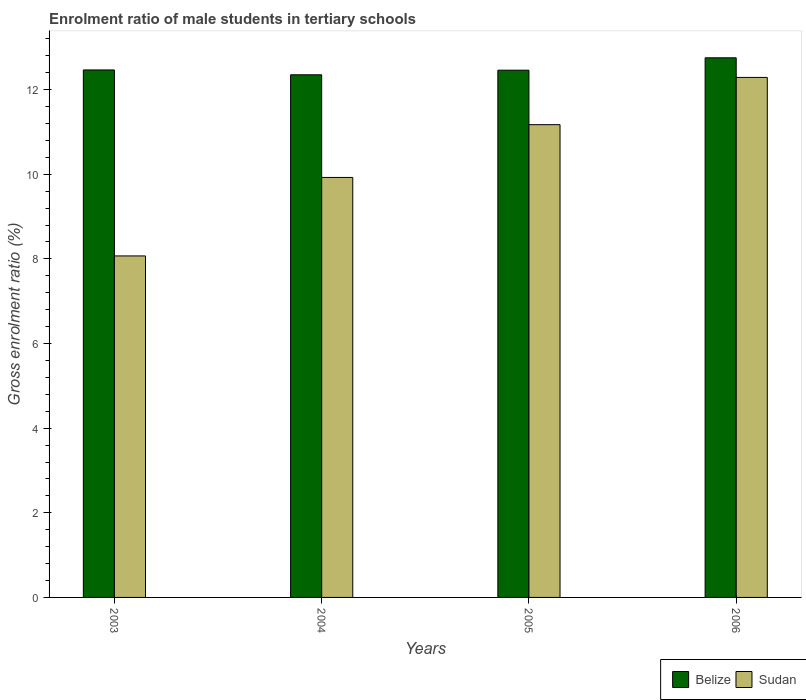How many different coloured bars are there?
Make the answer very short. 2. How many groups of bars are there?
Give a very brief answer. 4. Are the number of bars per tick equal to the number of legend labels?
Offer a very short reply. Yes. Are the number of bars on each tick of the X-axis equal?
Offer a terse response. Yes. How many bars are there on the 3rd tick from the left?
Your response must be concise. 2. What is the enrolment ratio of male students in tertiary schools in Sudan in 2004?
Your response must be concise. 9.92. Across all years, what is the maximum enrolment ratio of male students in tertiary schools in Sudan?
Provide a succinct answer. 12.29. Across all years, what is the minimum enrolment ratio of male students in tertiary schools in Sudan?
Your answer should be compact. 8.07. What is the total enrolment ratio of male students in tertiary schools in Sudan in the graph?
Offer a terse response. 41.45. What is the difference between the enrolment ratio of male students in tertiary schools in Belize in 2003 and that in 2005?
Your answer should be very brief. 0.01. What is the difference between the enrolment ratio of male students in tertiary schools in Sudan in 2003 and the enrolment ratio of male students in tertiary schools in Belize in 2004?
Offer a terse response. -4.28. What is the average enrolment ratio of male students in tertiary schools in Belize per year?
Offer a terse response. 12.51. In the year 2004, what is the difference between the enrolment ratio of male students in tertiary schools in Belize and enrolment ratio of male students in tertiary schools in Sudan?
Give a very brief answer. 2.43. What is the ratio of the enrolment ratio of male students in tertiary schools in Sudan in 2003 to that in 2004?
Keep it short and to the point. 0.81. Is the enrolment ratio of male students in tertiary schools in Sudan in 2003 less than that in 2005?
Provide a succinct answer. Yes. What is the difference between the highest and the second highest enrolment ratio of male students in tertiary schools in Sudan?
Your answer should be very brief. 1.12. What is the difference between the highest and the lowest enrolment ratio of male students in tertiary schools in Sudan?
Your response must be concise. 4.22. What does the 1st bar from the left in 2005 represents?
Provide a short and direct response. Belize. What does the 2nd bar from the right in 2005 represents?
Provide a short and direct response. Belize. How many bars are there?
Ensure brevity in your answer.  8. Are all the bars in the graph horizontal?
Provide a short and direct response. No. Does the graph contain any zero values?
Provide a short and direct response. No. How are the legend labels stacked?
Your answer should be compact. Horizontal. What is the title of the graph?
Give a very brief answer. Enrolment ratio of male students in tertiary schools. Does "Honduras" appear as one of the legend labels in the graph?
Your answer should be compact. No. What is the label or title of the Y-axis?
Your response must be concise. Gross enrolment ratio (%). What is the Gross enrolment ratio (%) of Belize in 2003?
Offer a terse response. 12.47. What is the Gross enrolment ratio (%) in Sudan in 2003?
Offer a terse response. 8.07. What is the Gross enrolment ratio (%) in Belize in 2004?
Your answer should be very brief. 12.35. What is the Gross enrolment ratio (%) of Sudan in 2004?
Your response must be concise. 9.92. What is the Gross enrolment ratio (%) in Belize in 2005?
Provide a succinct answer. 12.46. What is the Gross enrolment ratio (%) in Sudan in 2005?
Make the answer very short. 11.17. What is the Gross enrolment ratio (%) in Belize in 2006?
Make the answer very short. 12.75. What is the Gross enrolment ratio (%) of Sudan in 2006?
Your answer should be compact. 12.29. Across all years, what is the maximum Gross enrolment ratio (%) of Belize?
Keep it short and to the point. 12.75. Across all years, what is the maximum Gross enrolment ratio (%) of Sudan?
Your answer should be compact. 12.29. Across all years, what is the minimum Gross enrolment ratio (%) in Belize?
Your response must be concise. 12.35. Across all years, what is the minimum Gross enrolment ratio (%) in Sudan?
Provide a short and direct response. 8.07. What is the total Gross enrolment ratio (%) in Belize in the graph?
Offer a terse response. 50.03. What is the total Gross enrolment ratio (%) of Sudan in the graph?
Your answer should be very brief. 41.45. What is the difference between the Gross enrolment ratio (%) of Belize in 2003 and that in 2004?
Your response must be concise. 0.11. What is the difference between the Gross enrolment ratio (%) in Sudan in 2003 and that in 2004?
Your answer should be very brief. -1.85. What is the difference between the Gross enrolment ratio (%) in Belize in 2003 and that in 2005?
Your response must be concise. 0.01. What is the difference between the Gross enrolment ratio (%) of Sudan in 2003 and that in 2005?
Your answer should be very brief. -3.1. What is the difference between the Gross enrolment ratio (%) in Belize in 2003 and that in 2006?
Offer a very short reply. -0.29. What is the difference between the Gross enrolment ratio (%) of Sudan in 2003 and that in 2006?
Your response must be concise. -4.22. What is the difference between the Gross enrolment ratio (%) in Belize in 2004 and that in 2005?
Your answer should be compact. -0.11. What is the difference between the Gross enrolment ratio (%) of Sudan in 2004 and that in 2005?
Make the answer very short. -1.25. What is the difference between the Gross enrolment ratio (%) in Belize in 2004 and that in 2006?
Offer a very short reply. -0.4. What is the difference between the Gross enrolment ratio (%) of Sudan in 2004 and that in 2006?
Your answer should be very brief. -2.36. What is the difference between the Gross enrolment ratio (%) in Belize in 2005 and that in 2006?
Offer a very short reply. -0.29. What is the difference between the Gross enrolment ratio (%) in Sudan in 2005 and that in 2006?
Offer a terse response. -1.12. What is the difference between the Gross enrolment ratio (%) in Belize in 2003 and the Gross enrolment ratio (%) in Sudan in 2004?
Provide a succinct answer. 2.54. What is the difference between the Gross enrolment ratio (%) in Belize in 2003 and the Gross enrolment ratio (%) in Sudan in 2005?
Your answer should be very brief. 1.29. What is the difference between the Gross enrolment ratio (%) in Belize in 2003 and the Gross enrolment ratio (%) in Sudan in 2006?
Give a very brief answer. 0.18. What is the difference between the Gross enrolment ratio (%) in Belize in 2004 and the Gross enrolment ratio (%) in Sudan in 2005?
Keep it short and to the point. 1.18. What is the difference between the Gross enrolment ratio (%) of Belize in 2004 and the Gross enrolment ratio (%) of Sudan in 2006?
Your answer should be very brief. 0.06. What is the difference between the Gross enrolment ratio (%) in Belize in 2005 and the Gross enrolment ratio (%) in Sudan in 2006?
Give a very brief answer. 0.17. What is the average Gross enrolment ratio (%) in Belize per year?
Make the answer very short. 12.51. What is the average Gross enrolment ratio (%) of Sudan per year?
Ensure brevity in your answer.  10.36. In the year 2003, what is the difference between the Gross enrolment ratio (%) in Belize and Gross enrolment ratio (%) in Sudan?
Provide a succinct answer. 4.4. In the year 2004, what is the difference between the Gross enrolment ratio (%) in Belize and Gross enrolment ratio (%) in Sudan?
Keep it short and to the point. 2.43. In the year 2005, what is the difference between the Gross enrolment ratio (%) in Belize and Gross enrolment ratio (%) in Sudan?
Ensure brevity in your answer.  1.29. In the year 2006, what is the difference between the Gross enrolment ratio (%) of Belize and Gross enrolment ratio (%) of Sudan?
Your answer should be compact. 0.46. What is the ratio of the Gross enrolment ratio (%) of Belize in 2003 to that in 2004?
Your answer should be compact. 1.01. What is the ratio of the Gross enrolment ratio (%) in Sudan in 2003 to that in 2004?
Your answer should be very brief. 0.81. What is the ratio of the Gross enrolment ratio (%) in Sudan in 2003 to that in 2005?
Offer a terse response. 0.72. What is the ratio of the Gross enrolment ratio (%) of Belize in 2003 to that in 2006?
Provide a short and direct response. 0.98. What is the ratio of the Gross enrolment ratio (%) in Sudan in 2003 to that in 2006?
Offer a terse response. 0.66. What is the ratio of the Gross enrolment ratio (%) of Sudan in 2004 to that in 2005?
Make the answer very short. 0.89. What is the ratio of the Gross enrolment ratio (%) of Belize in 2004 to that in 2006?
Offer a terse response. 0.97. What is the ratio of the Gross enrolment ratio (%) in Sudan in 2004 to that in 2006?
Your response must be concise. 0.81. What is the difference between the highest and the second highest Gross enrolment ratio (%) in Belize?
Offer a very short reply. 0.29. What is the difference between the highest and the second highest Gross enrolment ratio (%) in Sudan?
Your answer should be very brief. 1.12. What is the difference between the highest and the lowest Gross enrolment ratio (%) of Belize?
Ensure brevity in your answer.  0.4. What is the difference between the highest and the lowest Gross enrolment ratio (%) in Sudan?
Your answer should be compact. 4.22. 